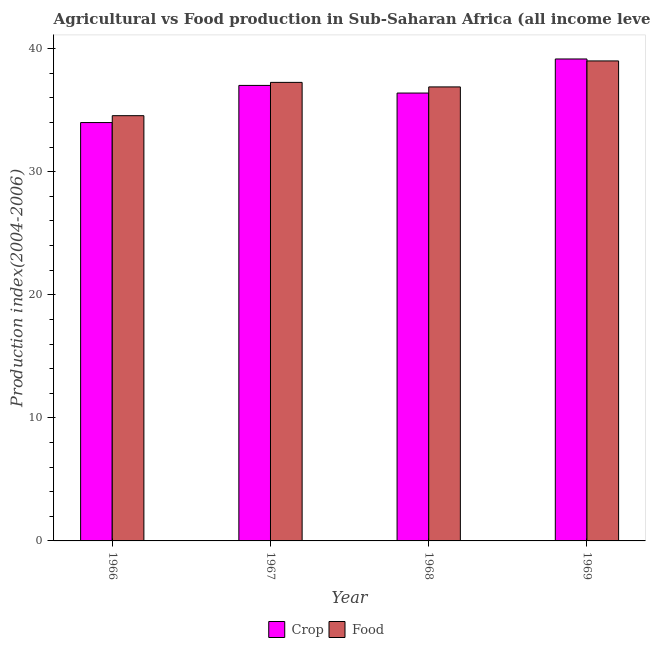How many different coloured bars are there?
Give a very brief answer. 2. Are the number of bars per tick equal to the number of legend labels?
Your answer should be compact. Yes. Are the number of bars on each tick of the X-axis equal?
Ensure brevity in your answer.  Yes. How many bars are there on the 1st tick from the right?
Your response must be concise. 2. What is the label of the 1st group of bars from the left?
Provide a short and direct response. 1966. In how many cases, is the number of bars for a given year not equal to the number of legend labels?
Offer a terse response. 0. What is the food production index in 1969?
Offer a very short reply. 39.01. Across all years, what is the maximum food production index?
Ensure brevity in your answer.  39.01. Across all years, what is the minimum food production index?
Your answer should be very brief. 34.56. In which year was the food production index maximum?
Your answer should be compact. 1969. In which year was the crop production index minimum?
Keep it short and to the point. 1966. What is the total crop production index in the graph?
Your answer should be very brief. 146.58. What is the difference between the crop production index in 1967 and that in 1969?
Your answer should be compact. -2.15. What is the difference between the crop production index in 1966 and the food production index in 1967?
Offer a terse response. -3.02. What is the average food production index per year?
Give a very brief answer. 36.93. In the year 1966, what is the difference between the food production index and crop production index?
Give a very brief answer. 0. What is the ratio of the food production index in 1966 to that in 1968?
Your answer should be very brief. 0.94. Is the food production index in 1966 less than that in 1967?
Give a very brief answer. Yes. What is the difference between the highest and the second highest food production index?
Offer a very short reply. 1.74. What is the difference between the highest and the lowest crop production index?
Give a very brief answer. 5.17. In how many years, is the food production index greater than the average food production index taken over all years?
Give a very brief answer. 2. What does the 2nd bar from the left in 1969 represents?
Give a very brief answer. Food. What does the 2nd bar from the right in 1966 represents?
Make the answer very short. Crop. How many bars are there?
Your response must be concise. 8. Does the graph contain any zero values?
Make the answer very short. No. Where does the legend appear in the graph?
Ensure brevity in your answer.  Bottom center. How are the legend labels stacked?
Your response must be concise. Horizontal. What is the title of the graph?
Provide a short and direct response. Agricultural vs Food production in Sub-Saharan Africa (all income levels) relative to the base period 2004-2006. What is the label or title of the Y-axis?
Ensure brevity in your answer.  Production index(2004-2006). What is the Production index(2004-2006) in Crop in 1966?
Provide a short and direct response. 34. What is the Production index(2004-2006) of Food in 1966?
Your answer should be compact. 34.56. What is the Production index(2004-2006) of Crop in 1967?
Offer a terse response. 37.02. What is the Production index(2004-2006) of Food in 1967?
Make the answer very short. 37.26. What is the Production index(2004-2006) of Crop in 1968?
Provide a short and direct response. 36.4. What is the Production index(2004-2006) of Food in 1968?
Your answer should be very brief. 36.9. What is the Production index(2004-2006) of Crop in 1969?
Ensure brevity in your answer.  39.17. What is the Production index(2004-2006) of Food in 1969?
Give a very brief answer. 39.01. Across all years, what is the maximum Production index(2004-2006) in Crop?
Make the answer very short. 39.17. Across all years, what is the maximum Production index(2004-2006) of Food?
Offer a very short reply. 39.01. Across all years, what is the minimum Production index(2004-2006) in Crop?
Offer a terse response. 34. Across all years, what is the minimum Production index(2004-2006) in Food?
Provide a succinct answer. 34.56. What is the total Production index(2004-2006) of Crop in the graph?
Your response must be concise. 146.58. What is the total Production index(2004-2006) of Food in the graph?
Ensure brevity in your answer.  147.72. What is the difference between the Production index(2004-2006) in Crop in 1966 and that in 1967?
Your answer should be very brief. -3.02. What is the difference between the Production index(2004-2006) in Food in 1966 and that in 1967?
Keep it short and to the point. -2.71. What is the difference between the Production index(2004-2006) of Crop in 1966 and that in 1968?
Offer a terse response. -2.4. What is the difference between the Production index(2004-2006) in Food in 1966 and that in 1968?
Give a very brief answer. -2.34. What is the difference between the Production index(2004-2006) of Crop in 1966 and that in 1969?
Your answer should be compact. -5.17. What is the difference between the Production index(2004-2006) in Food in 1966 and that in 1969?
Your answer should be compact. -4.45. What is the difference between the Production index(2004-2006) of Crop in 1967 and that in 1968?
Provide a succinct answer. 0.62. What is the difference between the Production index(2004-2006) of Food in 1967 and that in 1968?
Provide a short and direct response. 0.37. What is the difference between the Production index(2004-2006) of Crop in 1967 and that in 1969?
Offer a very short reply. -2.15. What is the difference between the Production index(2004-2006) of Food in 1967 and that in 1969?
Provide a short and direct response. -1.74. What is the difference between the Production index(2004-2006) of Crop in 1968 and that in 1969?
Your response must be concise. -2.77. What is the difference between the Production index(2004-2006) of Food in 1968 and that in 1969?
Provide a short and direct response. -2.11. What is the difference between the Production index(2004-2006) in Crop in 1966 and the Production index(2004-2006) in Food in 1967?
Your answer should be compact. -3.26. What is the difference between the Production index(2004-2006) of Crop in 1966 and the Production index(2004-2006) of Food in 1968?
Your response must be concise. -2.9. What is the difference between the Production index(2004-2006) in Crop in 1966 and the Production index(2004-2006) in Food in 1969?
Give a very brief answer. -5.01. What is the difference between the Production index(2004-2006) of Crop in 1967 and the Production index(2004-2006) of Food in 1968?
Provide a short and direct response. 0.12. What is the difference between the Production index(2004-2006) of Crop in 1967 and the Production index(2004-2006) of Food in 1969?
Provide a short and direct response. -1.99. What is the difference between the Production index(2004-2006) in Crop in 1968 and the Production index(2004-2006) in Food in 1969?
Keep it short and to the point. -2.61. What is the average Production index(2004-2006) in Crop per year?
Provide a succinct answer. 36.65. What is the average Production index(2004-2006) of Food per year?
Your answer should be compact. 36.93. In the year 1966, what is the difference between the Production index(2004-2006) of Crop and Production index(2004-2006) of Food?
Offer a terse response. -0.56. In the year 1967, what is the difference between the Production index(2004-2006) of Crop and Production index(2004-2006) of Food?
Provide a short and direct response. -0.25. In the year 1968, what is the difference between the Production index(2004-2006) of Crop and Production index(2004-2006) of Food?
Provide a short and direct response. -0.5. In the year 1969, what is the difference between the Production index(2004-2006) of Crop and Production index(2004-2006) of Food?
Offer a very short reply. 0.16. What is the ratio of the Production index(2004-2006) in Crop in 1966 to that in 1967?
Give a very brief answer. 0.92. What is the ratio of the Production index(2004-2006) in Food in 1966 to that in 1967?
Provide a short and direct response. 0.93. What is the ratio of the Production index(2004-2006) of Crop in 1966 to that in 1968?
Keep it short and to the point. 0.93. What is the ratio of the Production index(2004-2006) in Food in 1966 to that in 1968?
Offer a terse response. 0.94. What is the ratio of the Production index(2004-2006) in Crop in 1966 to that in 1969?
Provide a short and direct response. 0.87. What is the ratio of the Production index(2004-2006) in Food in 1966 to that in 1969?
Make the answer very short. 0.89. What is the ratio of the Production index(2004-2006) in Crop in 1967 to that in 1968?
Offer a terse response. 1.02. What is the ratio of the Production index(2004-2006) in Food in 1967 to that in 1968?
Offer a terse response. 1.01. What is the ratio of the Production index(2004-2006) of Crop in 1967 to that in 1969?
Provide a succinct answer. 0.95. What is the ratio of the Production index(2004-2006) of Food in 1967 to that in 1969?
Ensure brevity in your answer.  0.96. What is the ratio of the Production index(2004-2006) of Crop in 1968 to that in 1969?
Ensure brevity in your answer.  0.93. What is the ratio of the Production index(2004-2006) of Food in 1968 to that in 1969?
Keep it short and to the point. 0.95. What is the difference between the highest and the second highest Production index(2004-2006) of Crop?
Provide a succinct answer. 2.15. What is the difference between the highest and the second highest Production index(2004-2006) in Food?
Give a very brief answer. 1.74. What is the difference between the highest and the lowest Production index(2004-2006) in Crop?
Offer a very short reply. 5.17. What is the difference between the highest and the lowest Production index(2004-2006) in Food?
Your answer should be compact. 4.45. 